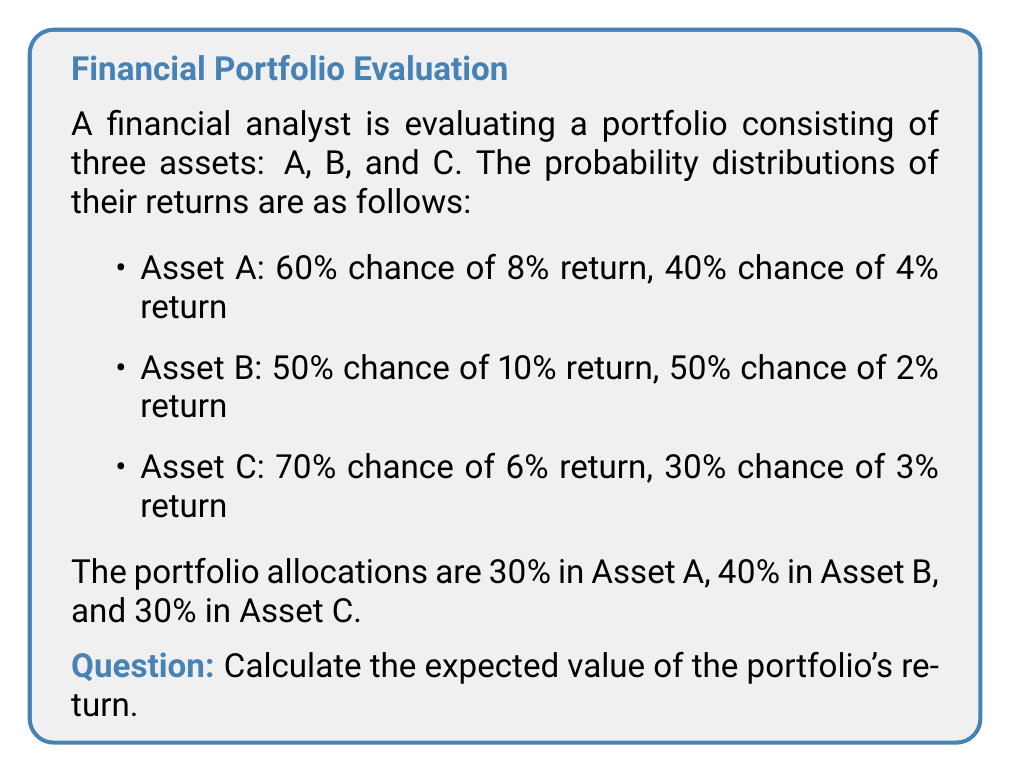Can you solve this math problem? To calculate the expected value of the portfolio's return, we need to follow these steps:

1. Calculate the expected return for each asset:

   Asset A: $E(R_A) = 0.60 \times 8\% + 0.40 \times 4\% = 6.4\%$
   Asset B: $E(R_B) = 0.50 \times 10\% + 0.50 \times 2\% = 6\%$
   Asset C: $E(R_C) = 0.70 \times 6\% + 0.30 \times 3\% = 5.1\%$

2. Multiply each asset's expected return by its portfolio allocation:

   Asset A: $0.30 \times 6.4\% = 1.92\%$
   Asset B: $0.40 \times 6\% = 2.4\%$
   Asset C: $0.30 \times 5.1\% = 1.53\%$

3. Sum the weighted expected returns to get the portfolio's expected return:

   $E(R_p) = 1.92\% + 2.4\% + 1.53\% = 5.85\%$

The expected value of the portfolio's return is the sum of these weighted expected returns.
Answer: 5.85% 